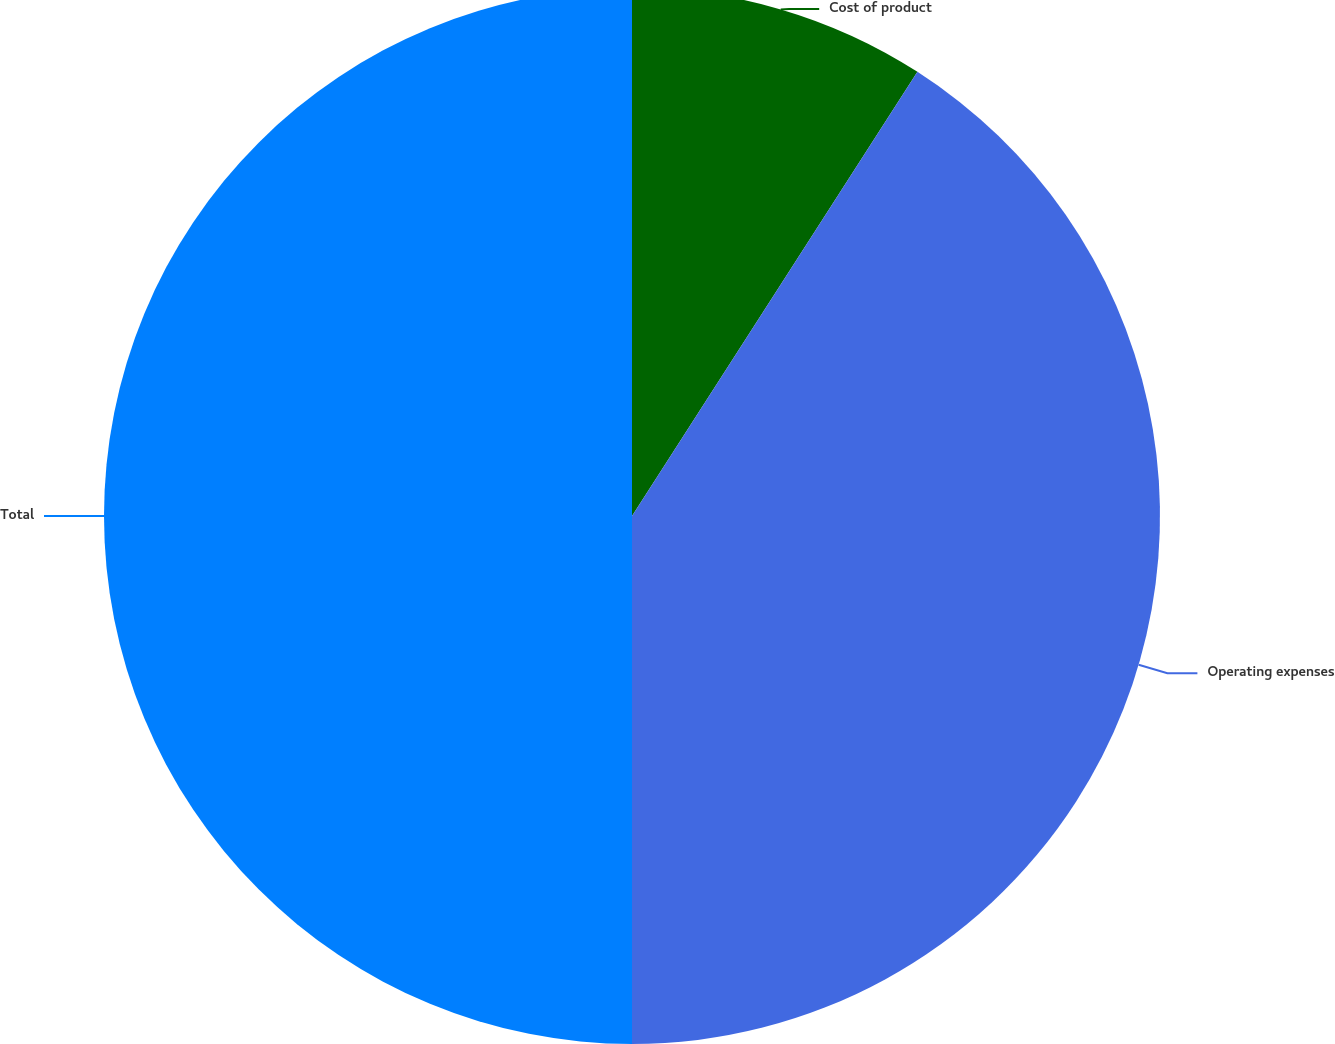<chart> <loc_0><loc_0><loc_500><loc_500><pie_chart><fcel>Cost of product<fcel>Operating expenses<fcel>Total<nl><fcel>9.09%<fcel>40.91%<fcel>50.0%<nl></chart> 